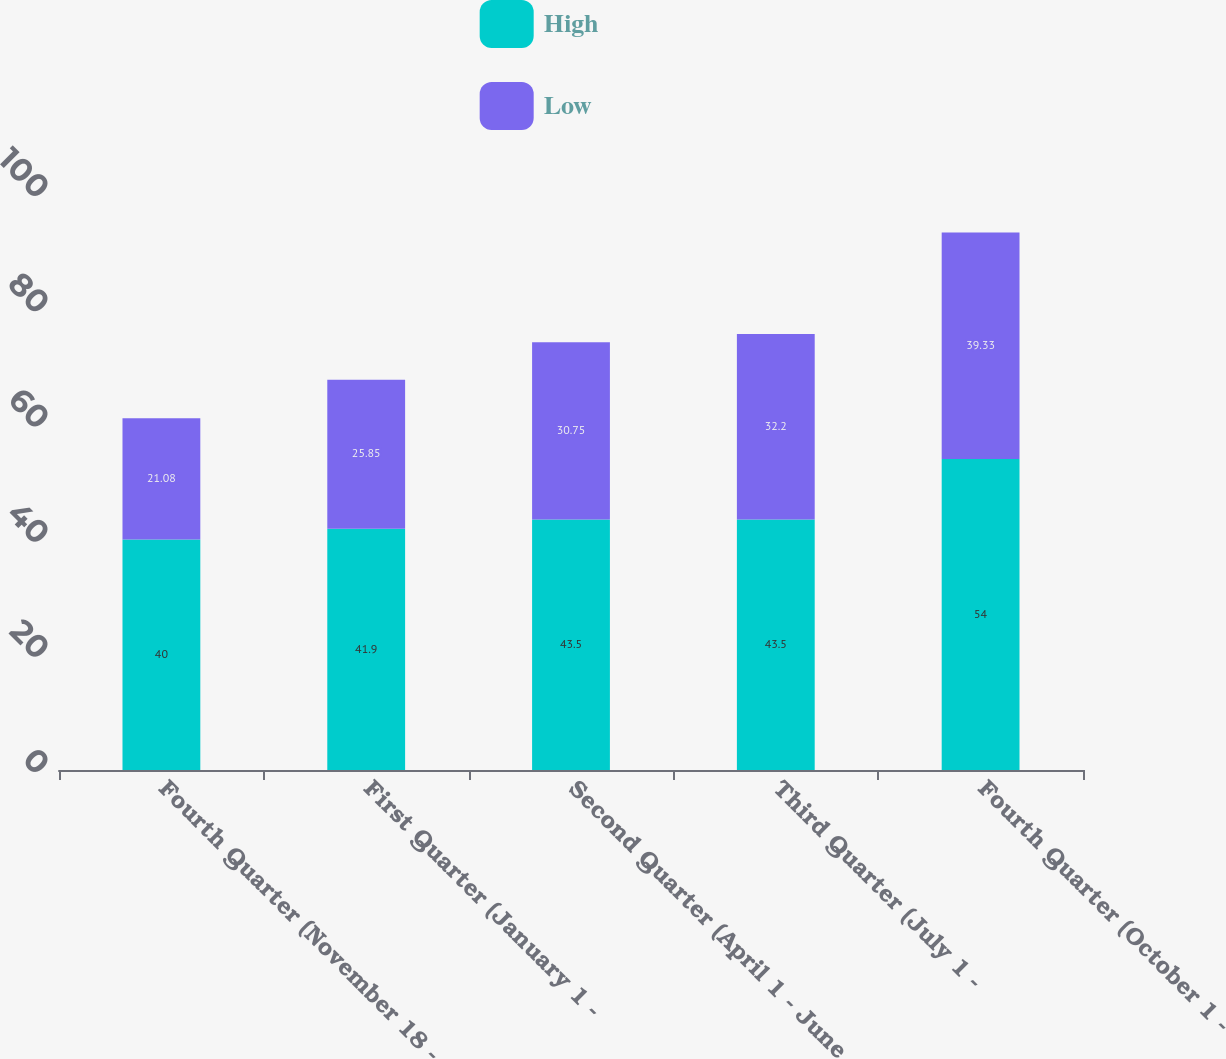Convert chart to OTSL. <chart><loc_0><loc_0><loc_500><loc_500><stacked_bar_chart><ecel><fcel>Fourth Quarter (November 18 -<fcel>First Quarter (January 1 -<fcel>Second Quarter (April 1 - June<fcel>Third Quarter (July 1 -<fcel>Fourth Quarter (October 1 -<nl><fcel>High<fcel>40<fcel>41.9<fcel>43.5<fcel>43.5<fcel>54<nl><fcel>Low<fcel>21.08<fcel>25.85<fcel>30.75<fcel>32.2<fcel>39.33<nl></chart> 